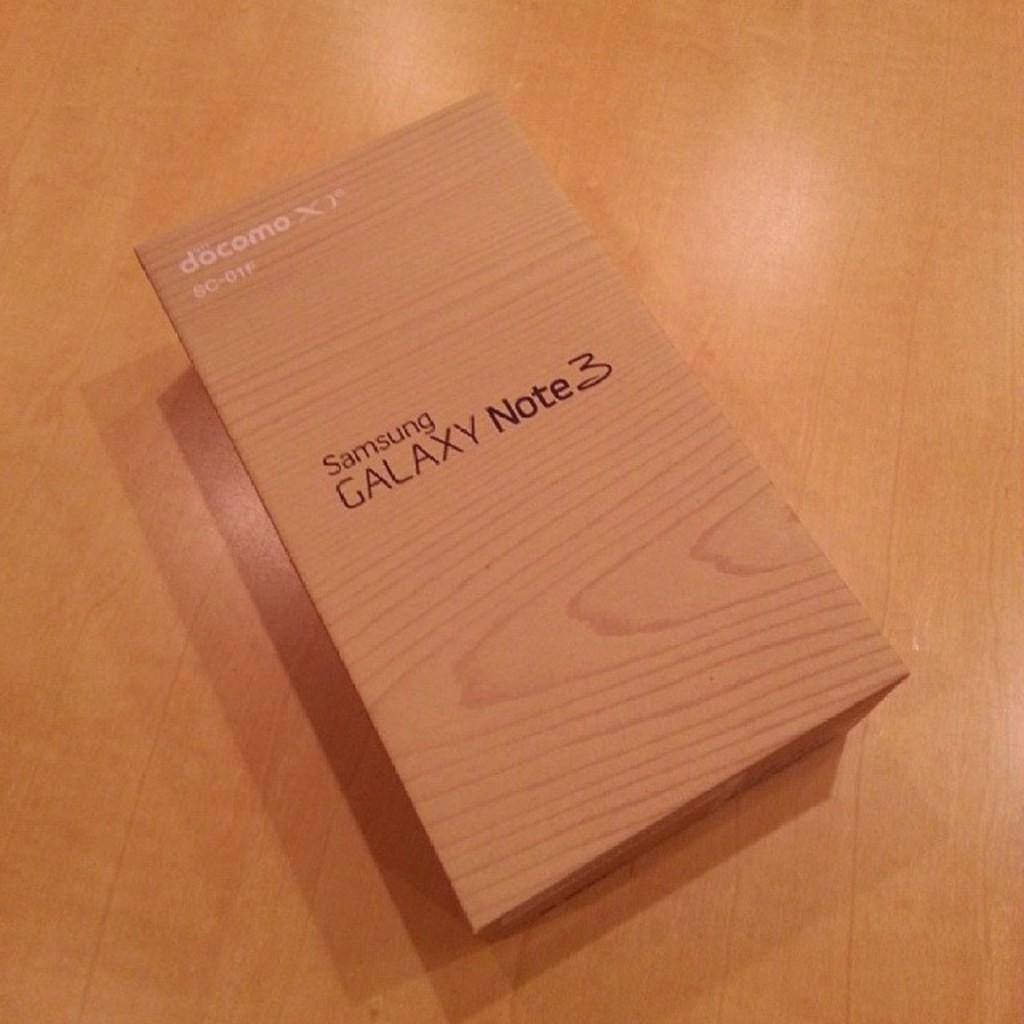<image>
Offer a succinct explanation of the picture presented. A wooden box for Samsung Galaxy Note 3 on a wooden table. 